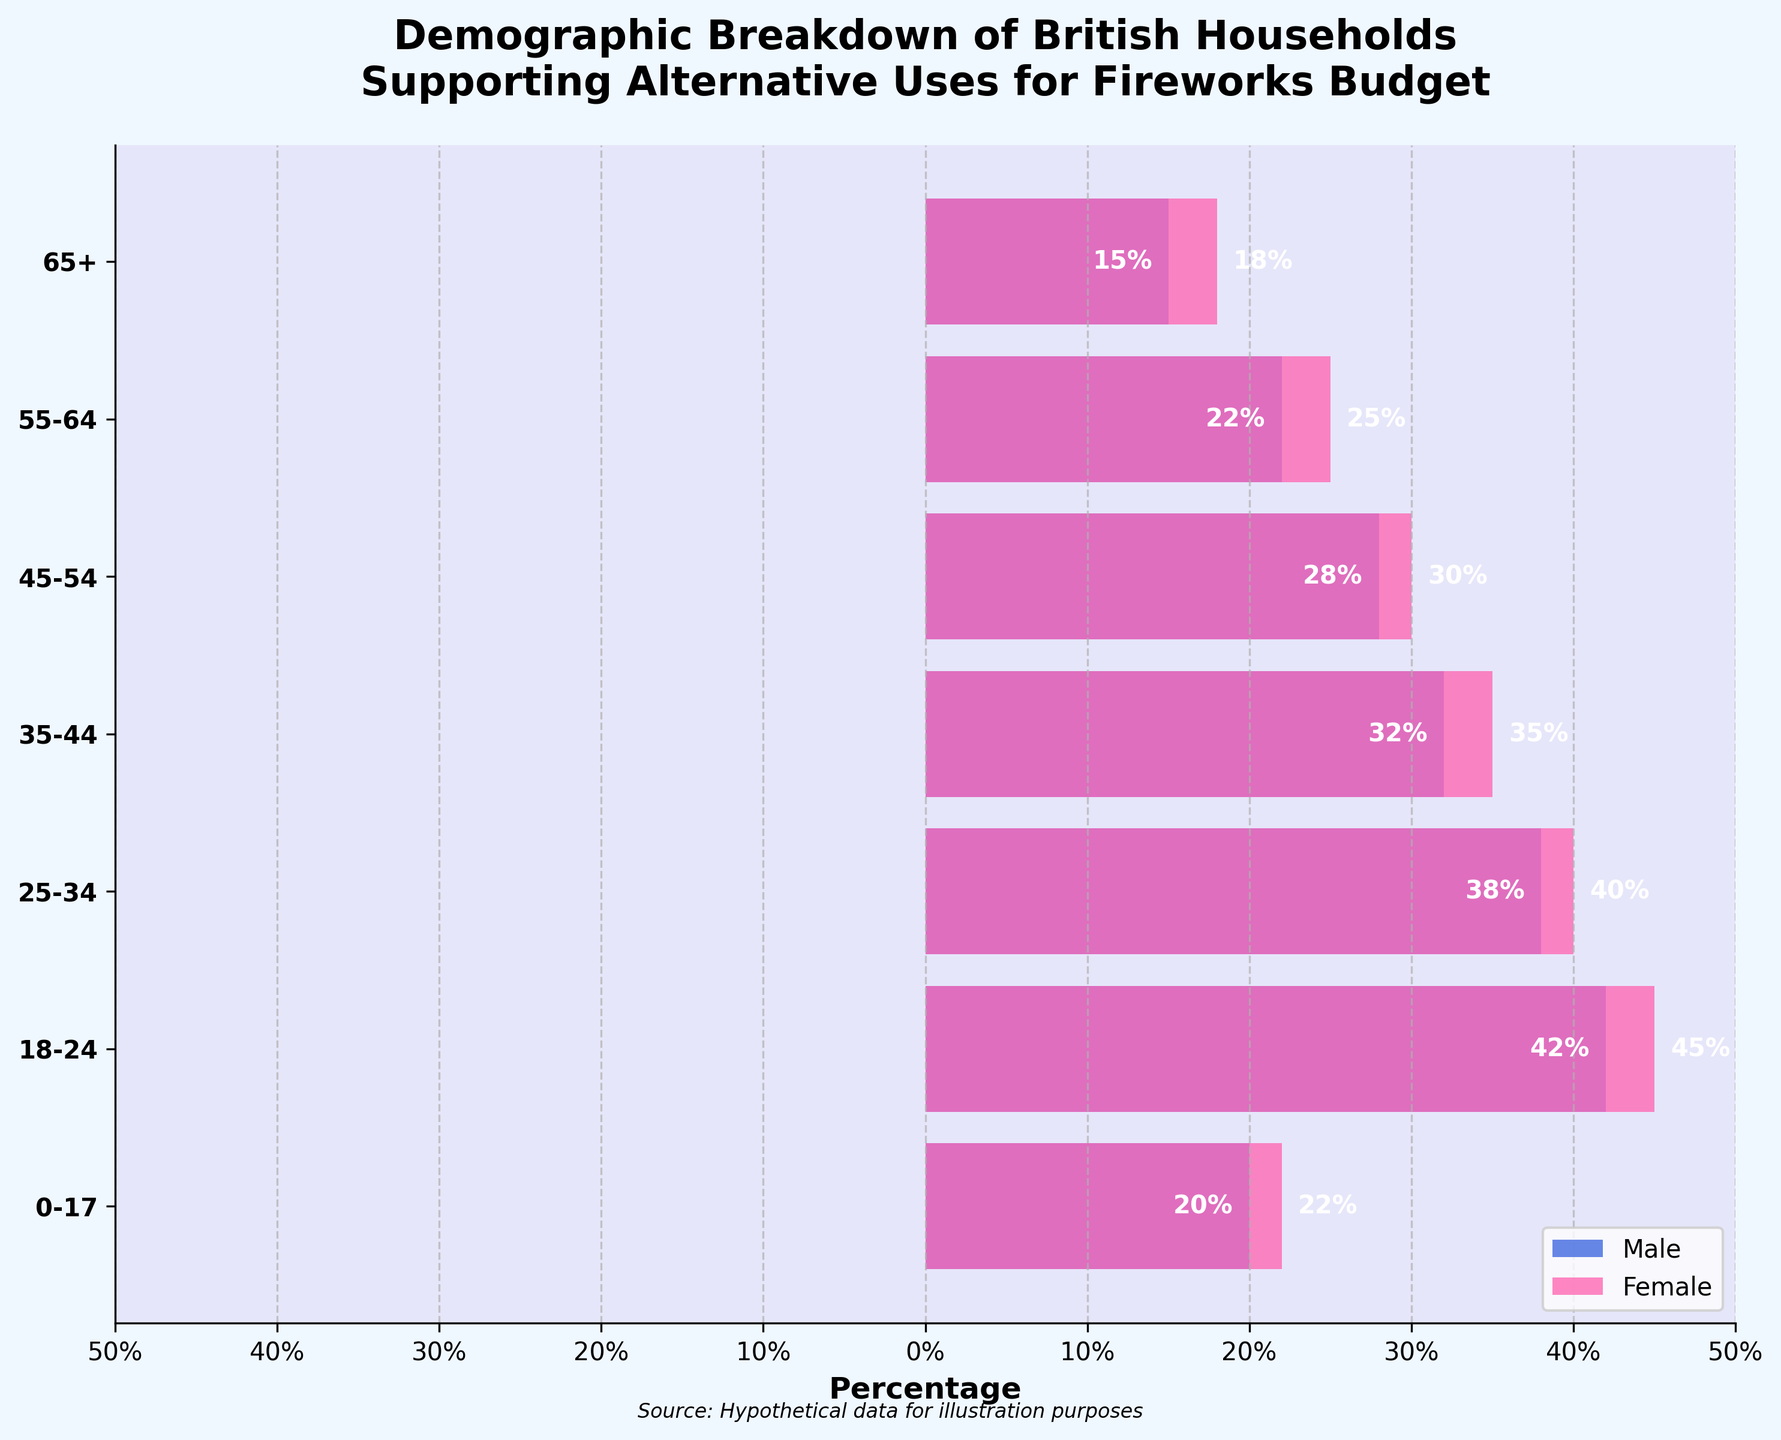What is the title of the figure? The title is usually located at the top center of the figure and provides an overview of the content. In this case, it reads: "Demographic Breakdown of British Households Supporting Alternative Uses for Fireworks Budget"
Answer: Demographic Breakdown of British Households Supporting Alternative Uses for Fireworks Budget What colors represent males and females in the plot? The colors used in the plot can be seen in the legend or directly from the bars. Males are represented by a blue color (#4169E1), and females are represented by a pink color (#FF69B4).
Answer: Blue for males and pink for females Which age group has the highest percentage, and what is it? To find the highest percentage, look at where the longest bars are. The 18-24 age group has the highest percentages: 42% for males and 45% for females. The highest percentage overall is 45% for females aged 18-24.
Answer: 45% for females aged 18-24 Which age group has the lowest percentage and what is it? To find the lowest percentage, look at the shortest bars. The 65+ age group has the lowest percentages: 15% for males and 18% for females. The lowest percentage overall is 15% for males aged 65+.
Answer: 15% for males aged 65+ What is the difference in percentage between males and females aged 45-54? To find the difference, subtract the percentage of males from the percentage of females within the same age group. For the 45-54 age group, it is 30% (females) - 28% (males) = 2%.
Answer: 2% How many age groups have a higher percentage of females compared to males? Examine each age group and count how many have longer bars for females than for males. All age groups (65+, 55-64, 45-54, 35-44, 25-34, 18-24, 0-17) have a higher percentage of females compared to males.
Answer: All 7 age groups What is the percentage difference between the youngest (0-17) and oldest (65+) age groups for females? For the youngest (0-17) age group, the female percentage is 22%, and for the oldest (65+), it is 18%. The difference is 22% - 18% = 4%.
Answer: 4% Which gender shows more consistent support across different age groups? By examining the variation in the lengths of the bars, we see that females have percentages that range from 18% to 45%, while males range from 15% to 42%. This indicates that female support for alternative uses of the fireworks budget is more consistently higher across age groups.
Answer: Females What's the sum of the percentages for the age group 25-34 for both males and females? Summing the percentages for this age group: 38% (males) + 40% (females) = 78%.
Answer: 78% What's the average percentage of males supporting alternative uses for the fireworks budget across all age groups? Add all the male percentages and divide by the number of age groups: (15 + 22 + 28 + 32 + 38 + 42 + 20) / 7 = 197 / 7 ≈ 28.14%.
Answer: ≈ 28.14% 